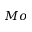Convert formula to latex. <formula><loc_0><loc_0><loc_500><loc_500>M o</formula> 